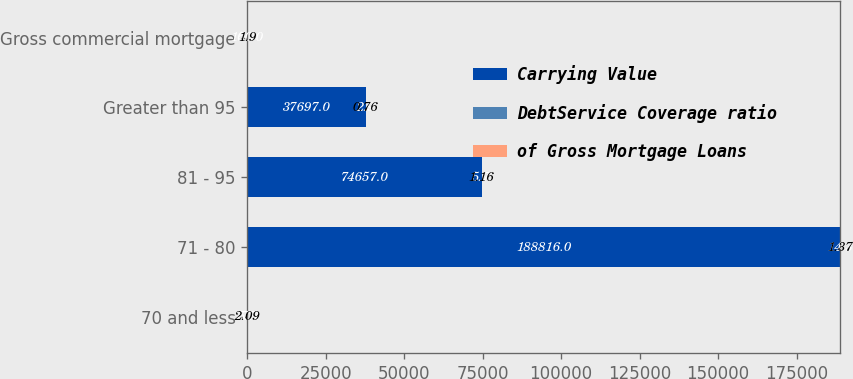Convert chart. <chart><loc_0><loc_0><loc_500><loc_500><stacked_bar_chart><ecel><fcel>70 and less<fcel>71 - 80<fcel>81 - 95<fcel>Greater than 95<fcel>Gross commercial mortgage<nl><fcel>Carrying Value<fcel>5.7<fcel>188816<fcel>74657<fcel>37697<fcel>5.7<nl><fcel>DebtService Coverage ratio<fcel>77.1<fcel>14.3<fcel>5.7<fcel>2.9<fcel>100<nl><fcel>of Gross Mortgage Loans<fcel>2.09<fcel>1.37<fcel>1.16<fcel>0.76<fcel>1.9<nl></chart> 